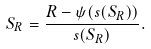<formula> <loc_0><loc_0><loc_500><loc_500>S _ { R } = \frac { R - \psi ( s ( S _ { R } ) ) } { s ( S _ { R } ) } .</formula> 